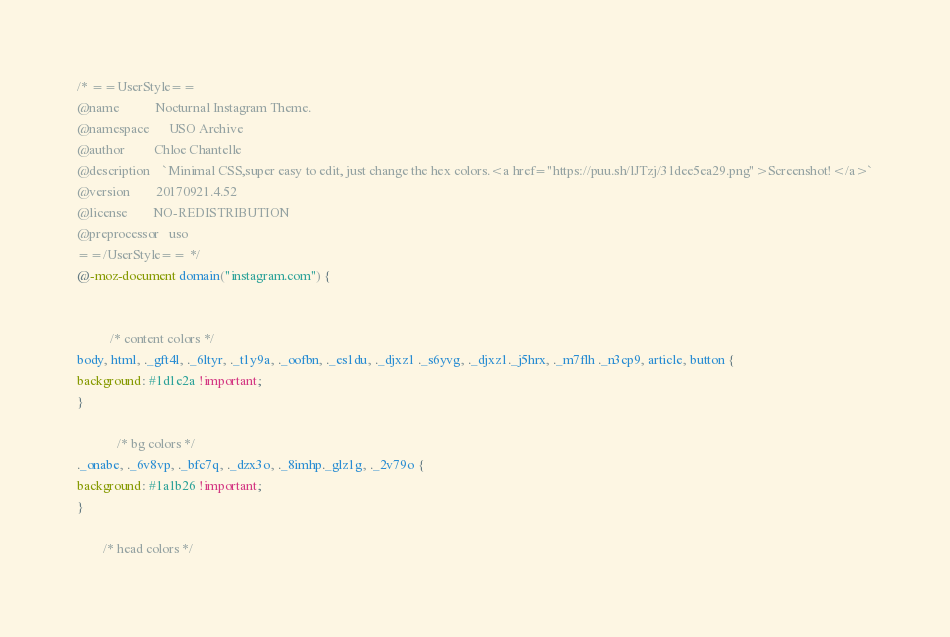Convert code to text. <code><loc_0><loc_0><loc_500><loc_500><_CSS_>/* ==UserStyle==
@name           Nocturnal Instagram Theme.
@namespace      USO Archive
@author         Chloe Chantelle
@description    `Minimal CSS,super easy to edit, just change the hex colors.<a href="https://puu.sh/lJTzj/31dee5ea29.png">Screenshot!</a>`
@version        20170921.4.52
@license        NO-REDISTRIBUTION
@preprocessor   uso
==/UserStyle== */
@-moz-document domain("instagram.com") {
  

          /* content colors */    
body, html, ._gft4l, ._6ltyr, ._t1y9a, ._oofbn, ._es1du, ._djxz1 ._s6yvg, ._djxz1._j5hrx, ._m7flh ._n3cp9, article, button {
background: #1d1e2a !important;    
}     
  
            /* bg colors */  
._onabe, ._6v8vp, ._bfc7q, ._dzx3o, ._8imhp._glz1g, ._2v79o {
background: #1a1b26 !important;
}
  
        /* head colors */  </code> 